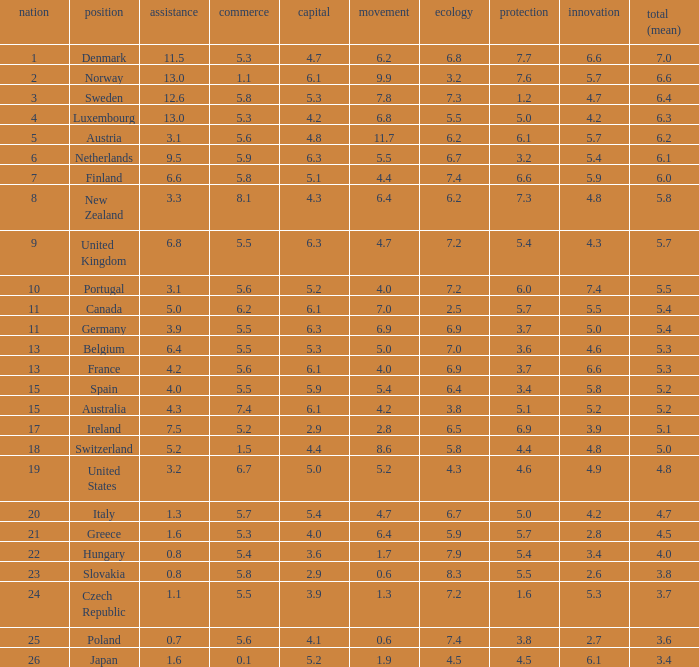What is the migration rating when trade is 5.7? 4.7. 